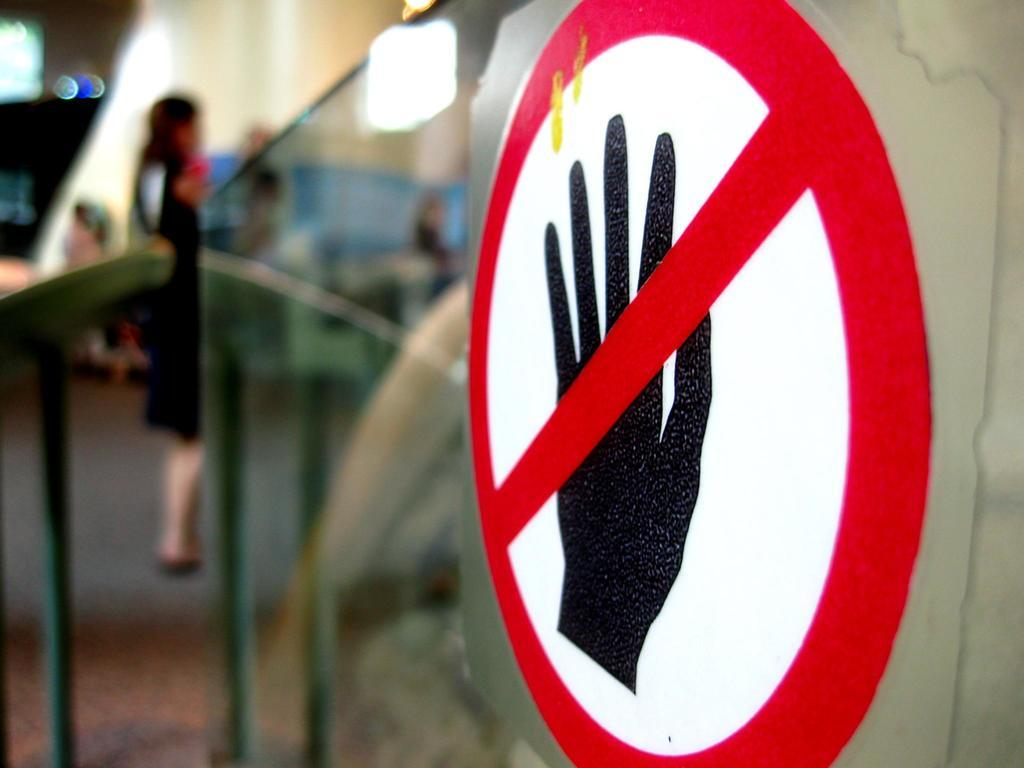What is the main object in the center of the image? There is a sign board in the center of the image. Can you describe anything in the background of the image? There is a woman standing in the background of the image. What is located next to the sign board in the image? There is a glass in the center of the image. What type of curtain is hanging from the sign board in the image? There is no curtain hanging from the sign board in the image. 